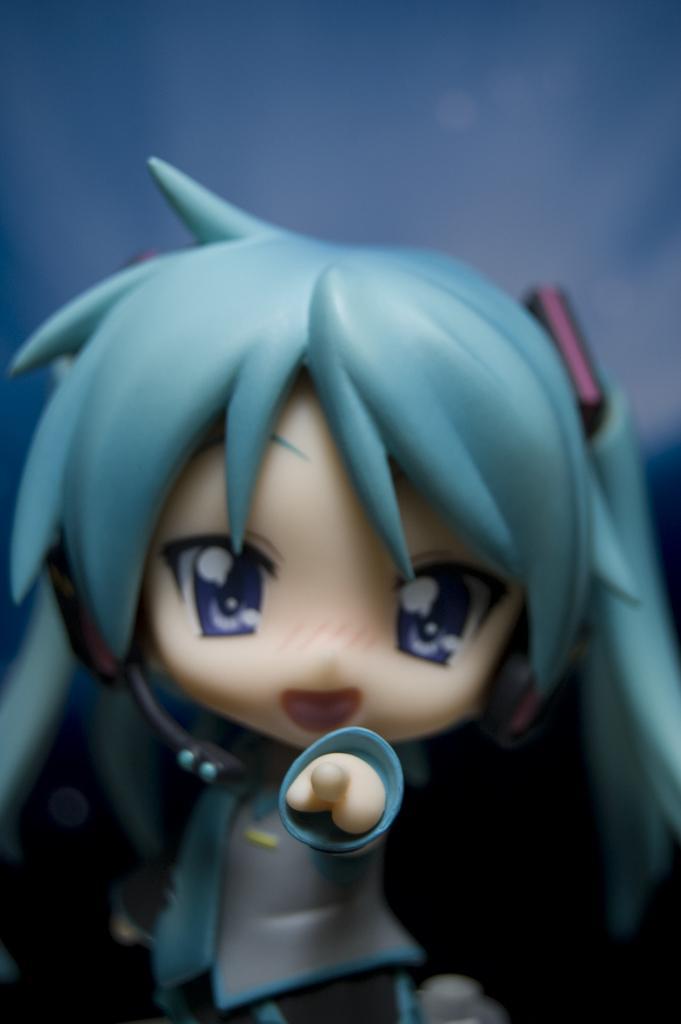Describe this image in one or two sentences. In the picture we can see girl doll with blue hair and behind it we can see the blue color background. 